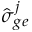Convert formula to latex. <formula><loc_0><loc_0><loc_500><loc_500>\hat { \sigma } _ { g e } ^ { j }</formula> 